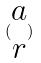Convert formula to latex. <formula><loc_0><loc_0><loc_500><loc_500>( \begin{matrix} a \\ r \end{matrix} )</formula> 